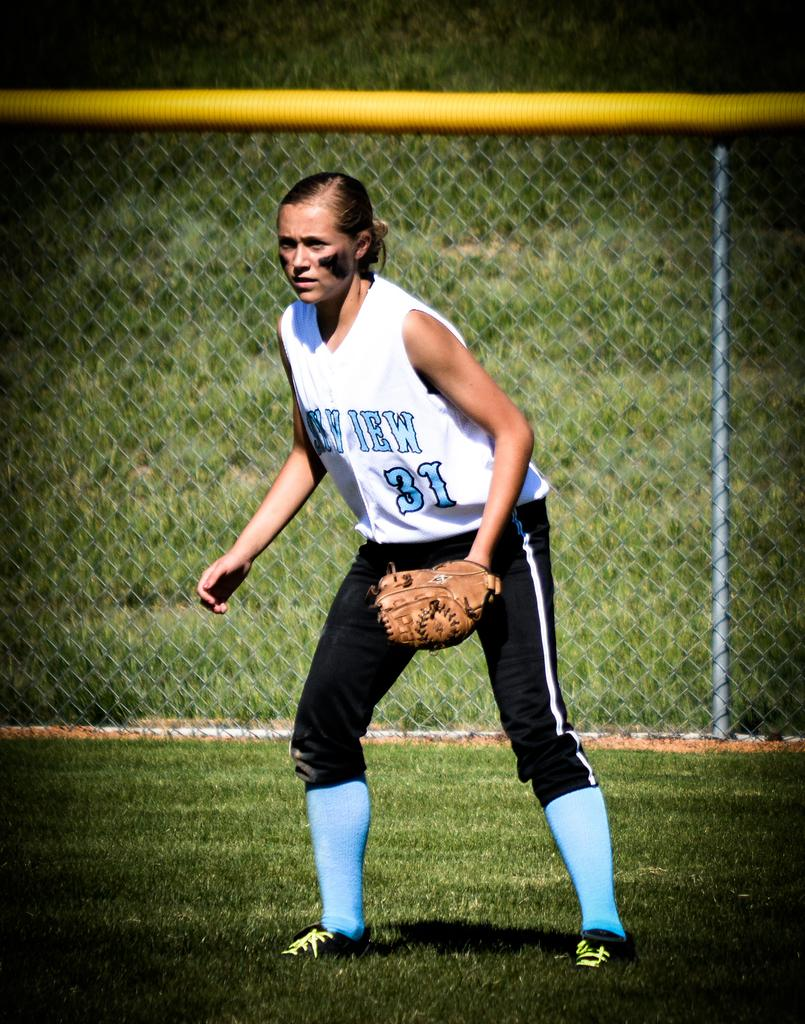<image>
Provide a brief description of the given image. number 31 is in the outfield playing a game 